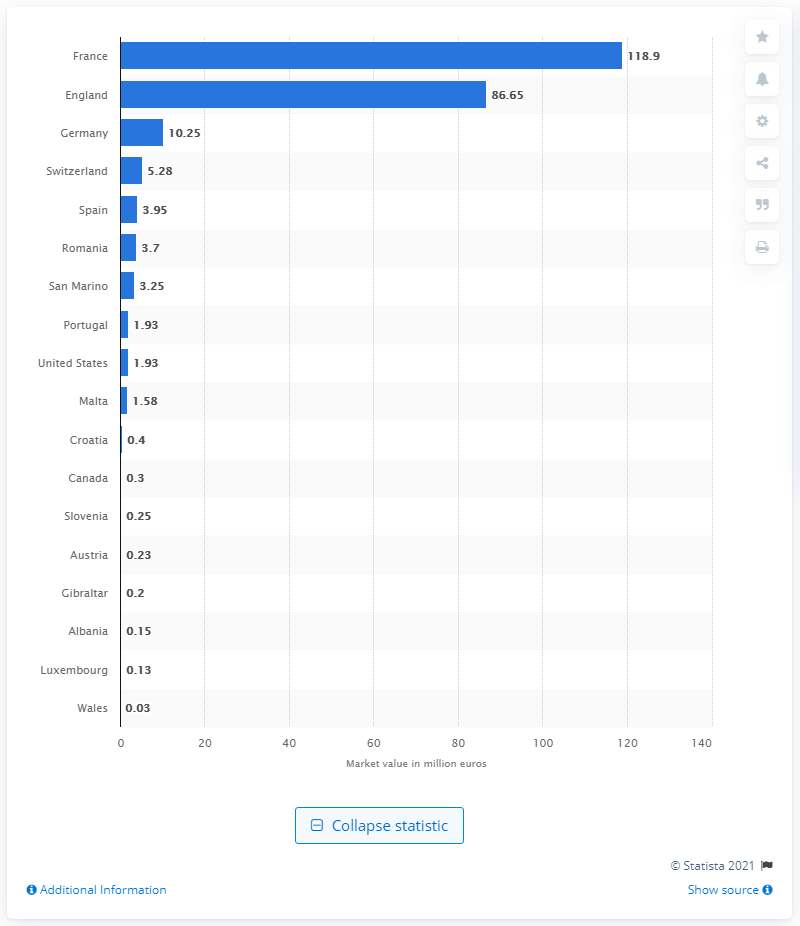Indicate a few pertinent items in this graphic. As of January 2021, the market value of Italian footballers playing in French teams was 118.9 million euros. 